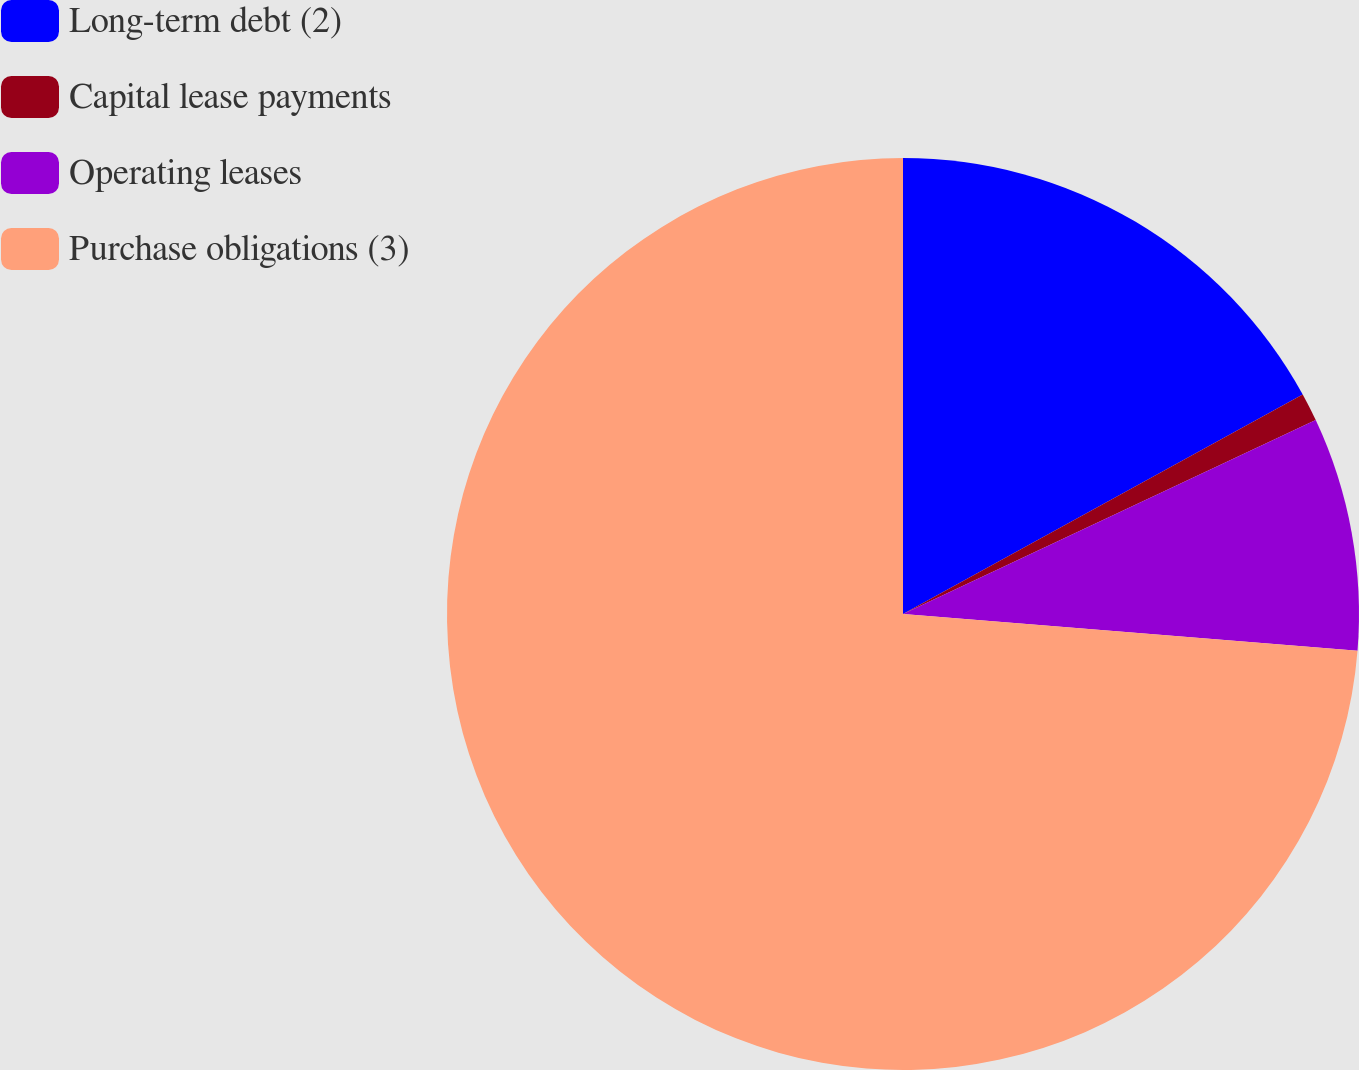<chart> <loc_0><loc_0><loc_500><loc_500><pie_chart><fcel>Long-term debt (2)<fcel>Capital lease payments<fcel>Operating leases<fcel>Purchase obligations (3)<nl><fcel>17.01%<fcel>1.0%<fcel>8.27%<fcel>73.72%<nl></chart> 